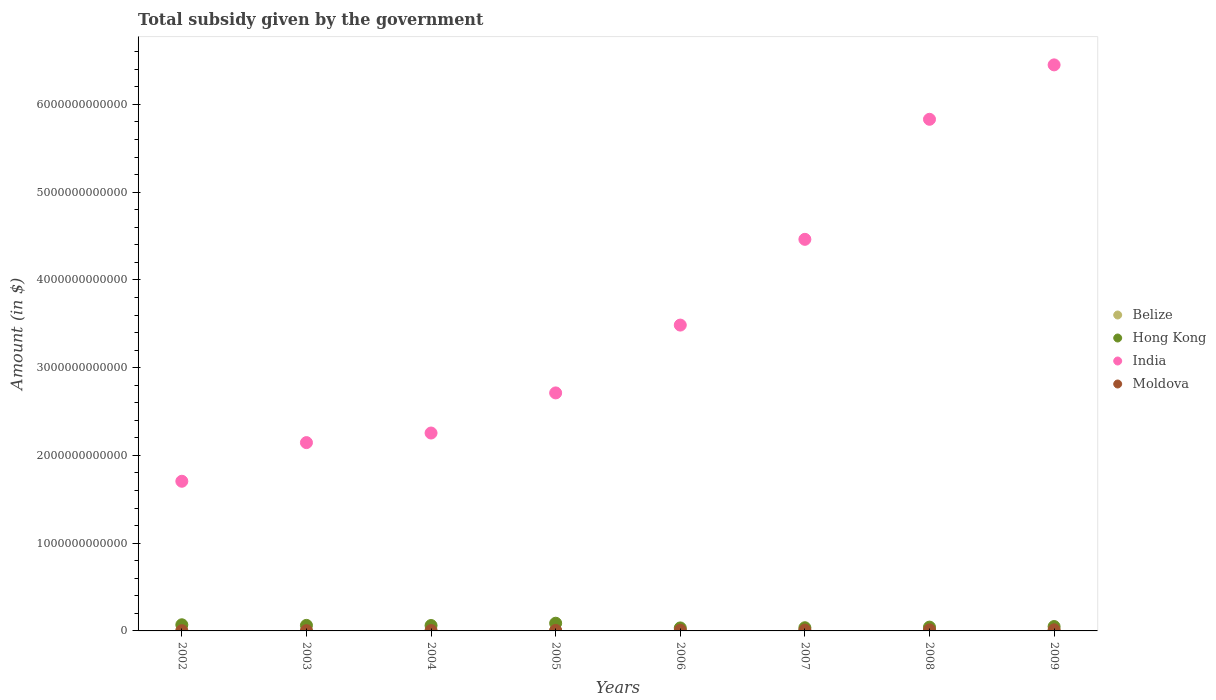How many different coloured dotlines are there?
Offer a very short reply. 4. Is the number of dotlines equal to the number of legend labels?
Make the answer very short. Yes. What is the total revenue collected by the government in Belize in 2003?
Your response must be concise. 5.55e+07. Across all years, what is the maximum total revenue collected by the government in Belize?
Offer a terse response. 1.41e+08. Across all years, what is the minimum total revenue collected by the government in Hong Kong?
Make the answer very short. 3.42e+1. What is the total total revenue collected by the government in Belize in the graph?
Make the answer very short. 7.35e+08. What is the difference between the total revenue collected by the government in India in 2004 and that in 2007?
Make the answer very short. -2.21e+12. What is the difference between the total revenue collected by the government in Hong Kong in 2005 and the total revenue collected by the government in India in 2007?
Keep it short and to the point. -4.37e+12. What is the average total revenue collected by the government in Moldova per year?
Your answer should be compact. 7.33e+09. In the year 2004, what is the difference between the total revenue collected by the government in Hong Kong and total revenue collected by the government in Moldova?
Make the answer very short. 5.74e+1. What is the ratio of the total revenue collected by the government in India in 2003 to that in 2005?
Your answer should be very brief. 0.79. Is the difference between the total revenue collected by the government in Hong Kong in 2006 and 2007 greater than the difference between the total revenue collected by the government in Moldova in 2006 and 2007?
Make the answer very short. No. What is the difference between the highest and the second highest total revenue collected by the government in Moldova?
Your answer should be very brief. 1.18e+09. What is the difference between the highest and the lowest total revenue collected by the government in India?
Offer a terse response. 4.74e+12. Is the total revenue collected by the government in Hong Kong strictly less than the total revenue collected by the government in India over the years?
Make the answer very short. Yes. How many dotlines are there?
Provide a short and direct response. 4. How many years are there in the graph?
Your answer should be compact. 8. What is the difference between two consecutive major ticks on the Y-axis?
Your response must be concise. 1.00e+12. Are the values on the major ticks of Y-axis written in scientific E-notation?
Your answer should be very brief. No. Does the graph contain any zero values?
Ensure brevity in your answer.  No. Where does the legend appear in the graph?
Your response must be concise. Center right. What is the title of the graph?
Keep it short and to the point. Total subsidy given by the government. Does "Korea (Republic)" appear as one of the legend labels in the graph?
Give a very brief answer. No. What is the label or title of the X-axis?
Your answer should be compact. Years. What is the label or title of the Y-axis?
Provide a short and direct response. Amount (in $). What is the Amount (in $) in Belize in 2002?
Offer a very short reply. 5.21e+07. What is the Amount (in $) in Hong Kong in 2002?
Provide a succinct answer. 7.00e+1. What is the Amount (in $) in India in 2002?
Give a very brief answer. 1.71e+12. What is the Amount (in $) of Moldova in 2002?
Your answer should be compact. 2.71e+09. What is the Amount (in $) of Belize in 2003?
Offer a very short reply. 5.55e+07. What is the Amount (in $) in Hong Kong in 2003?
Make the answer very short. 6.32e+1. What is the Amount (in $) in India in 2003?
Ensure brevity in your answer.  2.15e+12. What is the Amount (in $) of Moldova in 2003?
Provide a short and direct response. 3.20e+09. What is the Amount (in $) of Belize in 2004?
Your response must be concise. 6.60e+07. What is the Amount (in $) of Hong Kong in 2004?
Offer a terse response. 6.16e+1. What is the Amount (in $) in India in 2004?
Give a very brief answer. 2.26e+12. What is the Amount (in $) in Moldova in 2004?
Give a very brief answer. 4.26e+09. What is the Amount (in $) in Belize in 2005?
Keep it short and to the point. 7.71e+07. What is the Amount (in $) in Hong Kong in 2005?
Give a very brief answer. 8.78e+1. What is the Amount (in $) of India in 2005?
Provide a short and direct response. 2.71e+12. What is the Amount (in $) of Moldova in 2005?
Your response must be concise. 5.88e+09. What is the Amount (in $) in Belize in 2006?
Your answer should be compact. 9.24e+07. What is the Amount (in $) in Hong Kong in 2006?
Give a very brief answer. 3.42e+1. What is the Amount (in $) in India in 2006?
Provide a short and direct response. 3.49e+12. What is the Amount (in $) in Moldova in 2006?
Ensure brevity in your answer.  8.06e+09. What is the Amount (in $) in Belize in 2007?
Your answer should be very brief. 1.18e+08. What is the Amount (in $) of Hong Kong in 2007?
Your response must be concise. 3.64e+1. What is the Amount (in $) in India in 2007?
Your answer should be compact. 4.46e+12. What is the Amount (in $) in Moldova in 2007?
Provide a short and direct response. 9.77e+09. What is the Amount (in $) in Belize in 2008?
Offer a very short reply. 1.33e+08. What is the Amount (in $) in Hong Kong in 2008?
Make the answer very short. 4.33e+1. What is the Amount (in $) in India in 2008?
Provide a short and direct response. 5.83e+12. What is the Amount (in $) in Moldova in 2008?
Provide a succinct answer. 1.18e+1. What is the Amount (in $) of Belize in 2009?
Offer a very short reply. 1.41e+08. What is the Amount (in $) of Hong Kong in 2009?
Ensure brevity in your answer.  5.00e+1. What is the Amount (in $) of India in 2009?
Ensure brevity in your answer.  6.45e+12. What is the Amount (in $) in Moldova in 2009?
Your answer should be very brief. 1.30e+1. Across all years, what is the maximum Amount (in $) of Belize?
Give a very brief answer. 1.41e+08. Across all years, what is the maximum Amount (in $) of Hong Kong?
Offer a very short reply. 8.78e+1. Across all years, what is the maximum Amount (in $) of India?
Offer a terse response. 6.45e+12. Across all years, what is the maximum Amount (in $) of Moldova?
Ensure brevity in your answer.  1.30e+1. Across all years, what is the minimum Amount (in $) of Belize?
Your answer should be very brief. 5.21e+07. Across all years, what is the minimum Amount (in $) of Hong Kong?
Make the answer very short. 3.42e+1. Across all years, what is the minimum Amount (in $) of India?
Provide a short and direct response. 1.71e+12. Across all years, what is the minimum Amount (in $) in Moldova?
Offer a very short reply. 2.71e+09. What is the total Amount (in $) of Belize in the graph?
Your answer should be very brief. 7.35e+08. What is the total Amount (in $) in Hong Kong in the graph?
Your response must be concise. 4.46e+11. What is the total Amount (in $) of India in the graph?
Offer a very short reply. 2.90e+13. What is the total Amount (in $) in Moldova in the graph?
Your response must be concise. 5.86e+1. What is the difference between the Amount (in $) of Belize in 2002 and that in 2003?
Ensure brevity in your answer.  -3.42e+06. What is the difference between the Amount (in $) of Hong Kong in 2002 and that in 2003?
Offer a terse response. 6.82e+09. What is the difference between the Amount (in $) in India in 2002 and that in 2003?
Provide a short and direct response. -4.40e+11. What is the difference between the Amount (in $) in Moldova in 2002 and that in 2003?
Your response must be concise. -4.92e+08. What is the difference between the Amount (in $) of Belize in 2002 and that in 2004?
Make the answer very short. -1.38e+07. What is the difference between the Amount (in $) of Hong Kong in 2002 and that in 2004?
Keep it short and to the point. 8.37e+09. What is the difference between the Amount (in $) in India in 2002 and that in 2004?
Offer a terse response. -5.50e+11. What is the difference between the Amount (in $) of Moldova in 2002 and that in 2004?
Your response must be concise. -1.55e+09. What is the difference between the Amount (in $) of Belize in 2002 and that in 2005?
Ensure brevity in your answer.  -2.49e+07. What is the difference between the Amount (in $) of Hong Kong in 2002 and that in 2005?
Your answer should be compact. -1.78e+1. What is the difference between the Amount (in $) of India in 2002 and that in 2005?
Make the answer very short. -1.01e+12. What is the difference between the Amount (in $) in Moldova in 2002 and that in 2005?
Keep it short and to the point. -3.17e+09. What is the difference between the Amount (in $) in Belize in 2002 and that in 2006?
Your response must be concise. -4.03e+07. What is the difference between the Amount (in $) in Hong Kong in 2002 and that in 2006?
Provide a short and direct response. 3.58e+1. What is the difference between the Amount (in $) in India in 2002 and that in 2006?
Your answer should be very brief. -1.78e+12. What is the difference between the Amount (in $) of Moldova in 2002 and that in 2006?
Your answer should be compact. -5.35e+09. What is the difference between the Amount (in $) of Belize in 2002 and that in 2007?
Make the answer very short. -6.59e+07. What is the difference between the Amount (in $) in Hong Kong in 2002 and that in 2007?
Offer a terse response. 3.36e+1. What is the difference between the Amount (in $) in India in 2002 and that in 2007?
Your answer should be very brief. -2.76e+12. What is the difference between the Amount (in $) in Moldova in 2002 and that in 2007?
Your response must be concise. -7.06e+09. What is the difference between the Amount (in $) in Belize in 2002 and that in 2008?
Make the answer very short. -8.06e+07. What is the difference between the Amount (in $) of Hong Kong in 2002 and that in 2008?
Ensure brevity in your answer.  2.67e+1. What is the difference between the Amount (in $) of India in 2002 and that in 2008?
Keep it short and to the point. -4.12e+12. What is the difference between the Amount (in $) in Moldova in 2002 and that in 2008?
Give a very brief answer. -9.08e+09. What is the difference between the Amount (in $) in Belize in 2002 and that in 2009?
Give a very brief answer. -8.91e+07. What is the difference between the Amount (in $) in Hong Kong in 2002 and that in 2009?
Offer a terse response. 1.99e+1. What is the difference between the Amount (in $) of India in 2002 and that in 2009?
Ensure brevity in your answer.  -4.74e+12. What is the difference between the Amount (in $) in Moldova in 2002 and that in 2009?
Provide a short and direct response. -1.03e+1. What is the difference between the Amount (in $) of Belize in 2003 and that in 2004?
Provide a succinct answer. -1.04e+07. What is the difference between the Amount (in $) of Hong Kong in 2003 and that in 2004?
Offer a very short reply. 1.55e+09. What is the difference between the Amount (in $) of India in 2003 and that in 2004?
Keep it short and to the point. -1.09e+11. What is the difference between the Amount (in $) in Moldova in 2003 and that in 2004?
Provide a succinct answer. -1.06e+09. What is the difference between the Amount (in $) of Belize in 2003 and that in 2005?
Your response must be concise. -2.15e+07. What is the difference between the Amount (in $) of Hong Kong in 2003 and that in 2005?
Your response must be concise. -2.46e+1. What is the difference between the Amount (in $) of India in 2003 and that in 2005?
Your answer should be very brief. -5.66e+11. What is the difference between the Amount (in $) in Moldova in 2003 and that in 2005?
Your response must be concise. -2.68e+09. What is the difference between the Amount (in $) in Belize in 2003 and that in 2006?
Make the answer very short. -3.68e+07. What is the difference between the Amount (in $) of Hong Kong in 2003 and that in 2006?
Offer a very short reply. 2.90e+1. What is the difference between the Amount (in $) in India in 2003 and that in 2006?
Your answer should be compact. -1.34e+12. What is the difference between the Amount (in $) of Moldova in 2003 and that in 2006?
Your answer should be compact. -4.86e+09. What is the difference between the Amount (in $) of Belize in 2003 and that in 2007?
Your response must be concise. -6.25e+07. What is the difference between the Amount (in $) in Hong Kong in 2003 and that in 2007?
Make the answer very short. 2.68e+1. What is the difference between the Amount (in $) of India in 2003 and that in 2007?
Keep it short and to the point. -2.32e+12. What is the difference between the Amount (in $) in Moldova in 2003 and that in 2007?
Ensure brevity in your answer.  -6.57e+09. What is the difference between the Amount (in $) of Belize in 2003 and that in 2008?
Ensure brevity in your answer.  -7.71e+07. What is the difference between the Amount (in $) in Hong Kong in 2003 and that in 2008?
Give a very brief answer. 1.98e+1. What is the difference between the Amount (in $) of India in 2003 and that in 2008?
Give a very brief answer. -3.68e+12. What is the difference between the Amount (in $) of Moldova in 2003 and that in 2008?
Keep it short and to the point. -8.59e+09. What is the difference between the Amount (in $) of Belize in 2003 and that in 2009?
Make the answer very short. -8.56e+07. What is the difference between the Amount (in $) in Hong Kong in 2003 and that in 2009?
Provide a short and direct response. 1.31e+1. What is the difference between the Amount (in $) of India in 2003 and that in 2009?
Make the answer very short. -4.30e+12. What is the difference between the Amount (in $) in Moldova in 2003 and that in 2009?
Your response must be concise. -9.77e+09. What is the difference between the Amount (in $) in Belize in 2004 and that in 2005?
Keep it short and to the point. -1.11e+07. What is the difference between the Amount (in $) of Hong Kong in 2004 and that in 2005?
Keep it short and to the point. -2.62e+1. What is the difference between the Amount (in $) of India in 2004 and that in 2005?
Provide a succinct answer. -4.57e+11. What is the difference between the Amount (in $) of Moldova in 2004 and that in 2005?
Provide a short and direct response. -1.62e+09. What is the difference between the Amount (in $) in Belize in 2004 and that in 2006?
Provide a short and direct response. -2.64e+07. What is the difference between the Amount (in $) in Hong Kong in 2004 and that in 2006?
Your response must be concise. 2.75e+1. What is the difference between the Amount (in $) in India in 2004 and that in 2006?
Offer a terse response. -1.23e+12. What is the difference between the Amount (in $) in Moldova in 2004 and that in 2006?
Your answer should be compact. -3.80e+09. What is the difference between the Amount (in $) in Belize in 2004 and that in 2007?
Give a very brief answer. -5.20e+07. What is the difference between the Amount (in $) in Hong Kong in 2004 and that in 2007?
Provide a short and direct response. 2.53e+1. What is the difference between the Amount (in $) of India in 2004 and that in 2007?
Provide a succinct answer. -2.21e+12. What is the difference between the Amount (in $) in Moldova in 2004 and that in 2007?
Your answer should be compact. -5.51e+09. What is the difference between the Amount (in $) of Belize in 2004 and that in 2008?
Your answer should be very brief. -6.67e+07. What is the difference between the Amount (in $) of Hong Kong in 2004 and that in 2008?
Provide a short and direct response. 1.83e+1. What is the difference between the Amount (in $) of India in 2004 and that in 2008?
Give a very brief answer. -3.58e+12. What is the difference between the Amount (in $) in Moldova in 2004 and that in 2008?
Ensure brevity in your answer.  -7.53e+09. What is the difference between the Amount (in $) of Belize in 2004 and that in 2009?
Offer a terse response. -7.52e+07. What is the difference between the Amount (in $) of Hong Kong in 2004 and that in 2009?
Provide a short and direct response. 1.16e+1. What is the difference between the Amount (in $) of India in 2004 and that in 2009?
Ensure brevity in your answer.  -4.20e+12. What is the difference between the Amount (in $) in Moldova in 2004 and that in 2009?
Make the answer very short. -8.71e+09. What is the difference between the Amount (in $) in Belize in 2005 and that in 2006?
Provide a short and direct response. -1.53e+07. What is the difference between the Amount (in $) in Hong Kong in 2005 and that in 2006?
Provide a succinct answer. 5.36e+1. What is the difference between the Amount (in $) of India in 2005 and that in 2006?
Offer a very short reply. -7.73e+11. What is the difference between the Amount (in $) in Moldova in 2005 and that in 2006?
Offer a very short reply. -2.18e+09. What is the difference between the Amount (in $) of Belize in 2005 and that in 2007?
Your answer should be very brief. -4.09e+07. What is the difference between the Amount (in $) of Hong Kong in 2005 and that in 2007?
Offer a terse response. 5.14e+1. What is the difference between the Amount (in $) of India in 2005 and that in 2007?
Offer a very short reply. -1.75e+12. What is the difference between the Amount (in $) of Moldova in 2005 and that in 2007?
Ensure brevity in your answer.  -3.89e+09. What is the difference between the Amount (in $) in Belize in 2005 and that in 2008?
Offer a very short reply. -5.56e+07. What is the difference between the Amount (in $) in Hong Kong in 2005 and that in 2008?
Make the answer very short. 4.44e+1. What is the difference between the Amount (in $) in India in 2005 and that in 2008?
Make the answer very short. -3.12e+12. What is the difference between the Amount (in $) in Moldova in 2005 and that in 2008?
Give a very brief answer. -5.91e+09. What is the difference between the Amount (in $) of Belize in 2005 and that in 2009?
Give a very brief answer. -6.41e+07. What is the difference between the Amount (in $) in Hong Kong in 2005 and that in 2009?
Offer a terse response. 3.77e+1. What is the difference between the Amount (in $) in India in 2005 and that in 2009?
Provide a succinct answer. -3.74e+12. What is the difference between the Amount (in $) in Moldova in 2005 and that in 2009?
Provide a short and direct response. -7.09e+09. What is the difference between the Amount (in $) of Belize in 2006 and that in 2007?
Keep it short and to the point. -2.56e+07. What is the difference between the Amount (in $) in Hong Kong in 2006 and that in 2007?
Ensure brevity in your answer.  -2.20e+09. What is the difference between the Amount (in $) of India in 2006 and that in 2007?
Ensure brevity in your answer.  -9.77e+11. What is the difference between the Amount (in $) in Moldova in 2006 and that in 2007?
Make the answer very short. -1.71e+09. What is the difference between the Amount (in $) of Belize in 2006 and that in 2008?
Offer a very short reply. -4.03e+07. What is the difference between the Amount (in $) in Hong Kong in 2006 and that in 2008?
Your response must be concise. -9.17e+09. What is the difference between the Amount (in $) in India in 2006 and that in 2008?
Give a very brief answer. -2.35e+12. What is the difference between the Amount (in $) in Moldova in 2006 and that in 2008?
Your response must be concise. -3.73e+09. What is the difference between the Amount (in $) of Belize in 2006 and that in 2009?
Give a very brief answer. -4.88e+07. What is the difference between the Amount (in $) in Hong Kong in 2006 and that in 2009?
Your answer should be very brief. -1.59e+1. What is the difference between the Amount (in $) of India in 2006 and that in 2009?
Give a very brief answer. -2.97e+12. What is the difference between the Amount (in $) in Moldova in 2006 and that in 2009?
Your answer should be compact. -4.91e+09. What is the difference between the Amount (in $) in Belize in 2007 and that in 2008?
Your response must be concise. -1.47e+07. What is the difference between the Amount (in $) in Hong Kong in 2007 and that in 2008?
Provide a short and direct response. -6.98e+09. What is the difference between the Amount (in $) in India in 2007 and that in 2008?
Keep it short and to the point. -1.37e+12. What is the difference between the Amount (in $) of Moldova in 2007 and that in 2008?
Offer a very short reply. -2.02e+09. What is the difference between the Amount (in $) of Belize in 2007 and that in 2009?
Keep it short and to the point. -2.32e+07. What is the difference between the Amount (in $) of Hong Kong in 2007 and that in 2009?
Provide a succinct answer. -1.37e+1. What is the difference between the Amount (in $) in India in 2007 and that in 2009?
Ensure brevity in your answer.  -1.99e+12. What is the difference between the Amount (in $) in Moldova in 2007 and that in 2009?
Provide a succinct answer. -3.20e+09. What is the difference between the Amount (in $) in Belize in 2008 and that in 2009?
Your answer should be compact. -8.50e+06. What is the difference between the Amount (in $) in Hong Kong in 2008 and that in 2009?
Keep it short and to the point. -6.72e+09. What is the difference between the Amount (in $) in India in 2008 and that in 2009?
Make the answer very short. -6.20e+11. What is the difference between the Amount (in $) of Moldova in 2008 and that in 2009?
Your response must be concise. -1.18e+09. What is the difference between the Amount (in $) of Belize in 2002 and the Amount (in $) of Hong Kong in 2003?
Give a very brief answer. -6.31e+1. What is the difference between the Amount (in $) of Belize in 2002 and the Amount (in $) of India in 2003?
Make the answer very short. -2.15e+12. What is the difference between the Amount (in $) of Belize in 2002 and the Amount (in $) of Moldova in 2003?
Ensure brevity in your answer.  -3.15e+09. What is the difference between the Amount (in $) in Hong Kong in 2002 and the Amount (in $) in India in 2003?
Make the answer very short. -2.08e+12. What is the difference between the Amount (in $) in Hong Kong in 2002 and the Amount (in $) in Moldova in 2003?
Offer a terse response. 6.68e+1. What is the difference between the Amount (in $) of India in 2002 and the Amount (in $) of Moldova in 2003?
Give a very brief answer. 1.70e+12. What is the difference between the Amount (in $) in Belize in 2002 and the Amount (in $) in Hong Kong in 2004?
Your response must be concise. -6.16e+1. What is the difference between the Amount (in $) of Belize in 2002 and the Amount (in $) of India in 2004?
Keep it short and to the point. -2.26e+12. What is the difference between the Amount (in $) of Belize in 2002 and the Amount (in $) of Moldova in 2004?
Ensure brevity in your answer.  -4.21e+09. What is the difference between the Amount (in $) in Hong Kong in 2002 and the Amount (in $) in India in 2004?
Provide a succinct answer. -2.19e+12. What is the difference between the Amount (in $) of Hong Kong in 2002 and the Amount (in $) of Moldova in 2004?
Your response must be concise. 6.57e+1. What is the difference between the Amount (in $) of India in 2002 and the Amount (in $) of Moldova in 2004?
Provide a short and direct response. 1.70e+12. What is the difference between the Amount (in $) in Belize in 2002 and the Amount (in $) in Hong Kong in 2005?
Ensure brevity in your answer.  -8.77e+1. What is the difference between the Amount (in $) of Belize in 2002 and the Amount (in $) of India in 2005?
Offer a very short reply. -2.71e+12. What is the difference between the Amount (in $) in Belize in 2002 and the Amount (in $) in Moldova in 2005?
Ensure brevity in your answer.  -5.83e+09. What is the difference between the Amount (in $) of Hong Kong in 2002 and the Amount (in $) of India in 2005?
Your answer should be compact. -2.64e+12. What is the difference between the Amount (in $) of Hong Kong in 2002 and the Amount (in $) of Moldova in 2005?
Provide a succinct answer. 6.41e+1. What is the difference between the Amount (in $) of India in 2002 and the Amount (in $) of Moldova in 2005?
Offer a terse response. 1.70e+12. What is the difference between the Amount (in $) in Belize in 2002 and the Amount (in $) in Hong Kong in 2006?
Ensure brevity in your answer.  -3.41e+1. What is the difference between the Amount (in $) of Belize in 2002 and the Amount (in $) of India in 2006?
Ensure brevity in your answer.  -3.49e+12. What is the difference between the Amount (in $) in Belize in 2002 and the Amount (in $) in Moldova in 2006?
Provide a succinct answer. -8.01e+09. What is the difference between the Amount (in $) in Hong Kong in 2002 and the Amount (in $) in India in 2006?
Provide a succinct answer. -3.42e+12. What is the difference between the Amount (in $) in Hong Kong in 2002 and the Amount (in $) in Moldova in 2006?
Make the answer very short. 6.19e+1. What is the difference between the Amount (in $) in India in 2002 and the Amount (in $) in Moldova in 2006?
Offer a terse response. 1.70e+12. What is the difference between the Amount (in $) in Belize in 2002 and the Amount (in $) in Hong Kong in 2007?
Offer a terse response. -3.63e+1. What is the difference between the Amount (in $) of Belize in 2002 and the Amount (in $) of India in 2007?
Keep it short and to the point. -4.46e+12. What is the difference between the Amount (in $) in Belize in 2002 and the Amount (in $) in Moldova in 2007?
Offer a very short reply. -9.72e+09. What is the difference between the Amount (in $) of Hong Kong in 2002 and the Amount (in $) of India in 2007?
Make the answer very short. -4.39e+12. What is the difference between the Amount (in $) of Hong Kong in 2002 and the Amount (in $) of Moldova in 2007?
Offer a terse response. 6.02e+1. What is the difference between the Amount (in $) of India in 2002 and the Amount (in $) of Moldova in 2007?
Give a very brief answer. 1.70e+12. What is the difference between the Amount (in $) in Belize in 2002 and the Amount (in $) in Hong Kong in 2008?
Offer a very short reply. -4.33e+1. What is the difference between the Amount (in $) of Belize in 2002 and the Amount (in $) of India in 2008?
Give a very brief answer. -5.83e+12. What is the difference between the Amount (in $) of Belize in 2002 and the Amount (in $) of Moldova in 2008?
Provide a succinct answer. -1.17e+1. What is the difference between the Amount (in $) of Hong Kong in 2002 and the Amount (in $) of India in 2008?
Offer a very short reply. -5.76e+12. What is the difference between the Amount (in $) in Hong Kong in 2002 and the Amount (in $) in Moldova in 2008?
Provide a short and direct response. 5.82e+1. What is the difference between the Amount (in $) of India in 2002 and the Amount (in $) of Moldova in 2008?
Your answer should be compact. 1.69e+12. What is the difference between the Amount (in $) of Belize in 2002 and the Amount (in $) of Hong Kong in 2009?
Provide a short and direct response. -5.00e+1. What is the difference between the Amount (in $) of Belize in 2002 and the Amount (in $) of India in 2009?
Give a very brief answer. -6.45e+12. What is the difference between the Amount (in $) of Belize in 2002 and the Amount (in $) of Moldova in 2009?
Ensure brevity in your answer.  -1.29e+1. What is the difference between the Amount (in $) of Hong Kong in 2002 and the Amount (in $) of India in 2009?
Ensure brevity in your answer.  -6.38e+12. What is the difference between the Amount (in $) in Hong Kong in 2002 and the Amount (in $) in Moldova in 2009?
Provide a short and direct response. 5.70e+1. What is the difference between the Amount (in $) of India in 2002 and the Amount (in $) of Moldova in 2009?
Your response must be concise. 1.69e+12. What is the difference between the Amount (in $) of Belize in 2003 and the Amount (in $) of Hong Kong in 2004?
Keep it short and to the point. -6.16e+1. What is the difference between the Amount (in $) of Belize in 2003 and the Amount (in $) of India in 2004?
Your response must be concise. -2.26e+12. What is the difference between the Amount (in $) of Belize in 2003 and the Amount (in $) of Moldova in 2004?
Provide a succinct answer. -4.20e+09. What is the difference between the Amount (in $) in Hong Kong in 2003 and the Amount (in $) in India in 2004?
Make the answer very short. -2.19e+12. What is the difference between the Amount (in $) in Hong Kong in 2003 and the Amount (in $) in Moldova in 2004?
Keep it short and to the point. 5.89e+1. What is the difference between the Amount (in $) in India in 2003 and the Amount (in $) in Moldova in 2004?
Your response must be concise. 2.14e+12. What is the difference between the Amount (in $) of Belize in 2003 and the Amount (in $) of Hong Kong in 2005?
Give a very brief answer. -8.77e+1. What is the difference between the Amount (in $) of Belize in 2003 and the Amount (in $) of India in 2005?
Your answer should be compact. -2.71e+12. What is the difference between the Amount (in $) of Belize in 2003 and the Amount (in $) of Moldova in 2005?
Make the answer very short. -5.82e+09. What is the difference between the Amount (in $) in Hong Kong in 2003 and the Amount (in $) in India in 2005?
Give a very brief answer. -2.65e+12. What is the difference between the Amount (in $) in Hong Kong in 2003 and the Amount (in $) in Moldova in 2005?
Ensure brevity in your answer.  5.73e+1. What is the difference between the Amount (in $) of India in 2003 and the Amount (in $) of Moldova in 2005?
Your answer should be compact. 2.14e+12. What is the difference between the Amount (in $) of Belize in 2003 and the Amount (in $) of Hong Kong in 2006?
Your answer should be compact. -3.41e+1. What is the difference between the Amount (in $) of Belize in 2003 and the Amount (in $) of India in 2006?
Provide a succinct answer. -3.49e+12. What is the difference between the Amount (in $) in Belize in 2003 and the Amount (in $) in Moldova in 2006?
Ensure brevity in your answer.  -8.01e+09. What is the difference between the Amount (in $) of Hong Kong in 2003 and the Amount (in $) of India in 2006?
Provide a short and direct response. -3.42e+12. What is the difference between the Amount (in $) in Hong Kong in 2003 and the Amount (in $) in Moldova in 2006?
Provide a short and direct response. 5.51e+1. What is the difference between the Amount (in $) in India in 2003 and the Amount (in $) in Moldova in 2006?
Give a very brief answer. 2.14e+12. What is the difference between the Amount (in $) in Belize in 2003 and the Amount (in $) in Hong Kong in 2007?
Provide a short and direct response. -3.63e+1. What is the difference between the Amount (in $) of Belize in 2003 and the Amount (in $) of India in 2007?
Your response must be concise. -4.46e+12. What is the difference between the Amount (in $) in Belize in 2003 and the Amount (in $) in Moldova in 2007?
Make the answer very short. -9.72e+09. What is the difference between the Amount (in $) in Hong Kong in 2003 and the Amount (in $) in India in 2007?
Offer a terse response. -4.40e+12. What is the difference between the Amount (in $) in Hong Kong in 2003 and the Amount (in $) in Moldova in 2007?
Give a very brief answer. 5.34e+1. What is the difference between the Amount (in $) of India in 2003 and the Amount (in $) of Moldova in 2007?
Keep it short and to the point. 2.14e+12. What is the difference between the Amount (in $) of Belize in 2003 and the Amount (in $) of Hong Kong in 2008?
Offer a very short reply. -4.33e+1. What is the difference between the Amount (in $) of Belize in 2003 and the Amount (in $) of India in 2008?
Offer a terse response. -5.83e+12. What is the difference between the Amount (in $) in Belize in 2003 and the Amount (in $) in Moldova in 2008?
Your answer should be compact. -1.17e+1. What is the difference between the Amount (in $) in Hong Kong in 2003 and the Amount (in $) in India in 2008?
Your answer should be very brief. -5.77e+12. What is the difference between the Amount (in $) of Hong Kong in 2003 and the Amount (in $) of Moldova in 2008?
Offer a terse response. 5.14e+1. What is the difference between the Amount (in $) of India in 2003 and the Amount (in $) of Moldova in 2008?
Your response must be concise. 2.13e+12. What is the difference between the Amount (in $) of Belize in 2003 and the Amount (in $) of Hong Kong in 2009?
Your answer should be compact. -5.00e+1. What is the difference between the Amount (in $) in Belize in 2003 and the Amount (in $) in India in 2009?
Your answer should be compact. -6.45e+12. What is the difference between the Amount (in $) of Belize in 2003 and the Amount (in $) of Moldova in 2009?
Give a very brief answer. -1.29e+1. What is the difference between the Amount (in $) of Hong Kong in 2003 and the Amount (in $) of India in 2009?
Provide a succinct answer. -6.39e+12. What is the difference between the Amount (in $) of Hong Kong in 2003 and the Amount (in $) of Moldova in 2009?
Provide a short and direct response. 5.02e+1. What is the difference between the Amount (in $) of India in 2003 and the Amount (in $) of Moldova in 2009?
Offer a terse response. 2.13e+12. What is the difference between the Amount (in $) in Belize in 2004 and the Amount (in $) in Hong Kong in 2005?
Ensure brevity in your answer.  -8.77e+1. What is the difference between the Amount (in $) of Belize in 2004 and the Amount (in $) of India in 2005?
Offer a terse response. -2.71e+12. What is the difference between the Amount (in $) in Belize in 2004 and the Amount (in $) in Moldova in 2005?
Your answer should be very brief. -5.81e+09. What is the difference between the Amount (in $) of Hong Kong in 2004 and the Amount (in $) of India in 2005?
Offer a terse response. -2.65e+12. What is the difference between the Amount (in $) of Hong Kong in 2004 and the Amount (in $) of Moldova in 2005?
Keep it short and to the point. 5.57e+1. What is the difference between the Amount (in $) in India in 2004 and the Amount (in $) in Moldova in 2005?
Offer a very short reply. 2.25e+12. What is the difference between the Amount (in $) of Belize in 2004 and the Amount (in $) of Hong Kong in 2006?
Your answer should be very brief. -3.41e+1. What is the difference between the Amount (in $) of Belize in 2004 and the Amount (in $) of India in 2006?
Ensure brevity in your answer.  -3.49e+12. What is the difference between the Amount (in $) of Belize in 2004 and the Amount (in $) of Moldova in 2006?
Ensure brevity in your answer.  -8.00e+09. What is the difference between the Amount (in $) of Hong Kong in 2004 and the Amount (in $) of India in 2006?
Your response must be concise. -3.42e+12. What is the difference between the Amount (in $) in Hong Kong in 2004 and the Amount (in $) in Moldova in 2006?
Offer a terse response. 5.36e+1. What is the difference between the Amount (in $) in India in 2004 and the Amount (in $) in Moldova in 2006?
Offer a very short reply. 2.25e+12. What is the difference between the Amount (in $) of Belize in 2004 and the Amount (in $) of Hong Kong in 2007?
Give a very brief answer. -3.63e+1. What is the difference between the Amount (in $) in Belize in 2004 and the Amount (in $) in India in 2007?
Your answer should be very brief. -4.46e+12. What is the difference between the Amount (in $) in Belize in 2004 and the Amount (in $) in Moldova in 2007?
Ensure brevity in your answer.  -9.71e+09. What is the difference between the Amount (in $) of Hong Kong in 2004 and the Amount (in $) of India in 2007?
Offer a terse response. -4.40e+12. What is the difference between the Amount (in $) in Hong Kong in 2004 and the Amount (in $) in Moldova in 2007?
Your answer should be compact. 5.18e+1. What is the difference between the Amount (in $) of India in 2004 and the Amount (in $) of Moldova in 2007?
Keep it short and to the point. 2.25e+12. What is the difference between the Amount (in $) in Belize in 2004 and the Amount (in $) in Hong Kong in 2008?
Offer a terse response. -4.33e+1. What is the difference between the Amount (in $) of Belize in 2004 and the Amount (in $) of India in 2008?
Give a very brief answer. -5.83e+12. What is the difference between the Amount (in $) of Belize in 2004 and the Amount (in $) of Moldova in 2008?
Offer a terse response. -1.17e+1. What is the difference between the Amount (in $) in Hong Kong in 2004 and the Amount (in $) in India in 2008?
Give a very brief answer. -5.77e+12. What is the difference between the Amount (in $) of Hong Kong in 2004 and the Amount (in $) of Moldova in 2008?
Make the answer very short. 4.98e+1. What is the difference between the Amount (in $) in India in 2004 and the Amount (in $) in Moldova in 2008?
Keep it short and to the point. 2.24e+12. What is the difference between the Amount (in $) in Belize in 2004 and the Amount (in $) in Hong Kong in 2009?
Your answer should be compact. -5.00e+1. What is the difference between the Amount (in $) of Belize in 2004 and the Amount (in $) of India in 2009?
Your answer should be very brief. -6.45e+12. What is the difference between the Amount (in $) of Belize in 2004 and the Amount (in $) of Moldova in 2009?
Your answer should be very brief. -1.29e+1. What is the difference between the Amount (in $) of Hong Kong in 2004 and the Amount (in $) of India in 2009?
Your response must be concise. -6.39e+12. What is the difference between the Amount (in $) in Hong Kong in 2004 and the Amount (in $) in Moldova in 2009?
Ensure brevity in your answer.  4.86e+1. What is the difference between the Amount (in $) of India in 2004 and the Amount (in $) of Moldova in 2009?
Your response must be concise. 2.24e+12. What is the difference between the Amount (in $) in Belize in 2005 and the Amount (in $) in Hong Kong in 2006?
Offer a very short reply. -3.41e+1. What is the difference between the Amount (in $) of Belize in 2005 and the Amount (in $) of India in 2006?
Your response must be concise. -3.49e+12. What is the difference between the Amount (in $) in Belize in 2005 and the Amount (in $) in Moldova in 2006?
Provide a short and direct response. -7.99e+09. What is the difference between the Amount (in $) of Hong Kong in 2005 and the Amount (in $) of India in 2006?
Keep it short and to the point. -3.40e+12. What is the difference between the Amount (in $) of Hong Kong in 2005 and the Amount (in $) of Moldova in 2006?
Your answer should be compact. 7.97e+1. What is the difference between the Amount (in $) in India in 2005 and the Amount (in $) in Moldova in 2006?
Keep it short and to the point. 2.70e+12. What is the difference between the Amount (in $) of Belize in 2005 and the Amount (in $) of Hong Kong in 2007?
Offer a very short reply. -3.63e+1. What is the difference between the Amount (in $) in Belize in 2005 and the Amount (in $) in India in 2007?
Ensure brevity in your answer.  -4.46e+12. What is the difference between the Amount (in $) of Belize in 2005 and the Amount (in $) of Moldova in 2007?
Offer a very short reply. -9.69e+09. What is the difference between the Amount (in $) in Hong Kong in 2005 and the Amount (in $) in India in 2007?
Offer a terse response. -4.37e+12. What is the difference between the Amount (in $) of Hong Kong in 2005 and the Amount (in $) of Moldova in 2007?
Your response must be concise. 7.80e+1. What is the difference between the Amount (in $) of India in 2005 and the Amount (in $) of Moldova in 2007?
Ensure brevity in your answer.  2.70e+12. What is the difference between the Amount (in $) in Belize in 2005 and the Amount (in $) in Hong Kong in 2008?
Your response must be concise. -4.33e+1. What is the difference between the Amount (in $) of Belize in 2005 and the Amount (in $) of India in 2008?
Your answer should be compact. -5.83e+12. What is the difference between the Amount (in $) in Belize in 2005 and the Amount (in $) in Moldova in 2008?
Offer a terse response. -1.17e+1. What is the difference between the Amount (in $) of Hong Kong in 2005 and the Amount (in $) of India in 2008?
Make the answer very short. -5.74e+12. What is the difference between the Amount (in $) of Hong Kong in 2005 and the Amount (in $) of Moldova in 2008?
Your answer should be compact. 7.60e+1. What is the difference between the Amount (in $) in India in 2005 and the Amount (in $) in Moldova in 2008?
Your answer should be compact. 2.70e+12. What is the difference between the Amount (in $) in Belize in 2005 and the Amount (in $) in Hong Kong in 2009?
Provide a succinct answer. -5.00e+1. What is the difference between the Amount (in $) of Belize in 2005 and the Amount (in $) of India in 2009?
Provide a succinct answer. -6.45e+12. What is the difference between the Amount (in $) of Belize in 2005 and the Amount (in $) of Moldova in 2009?
Provide a short and direct response. -1.29e+1. What is the difference between the Amount (in $) in Hong Kong in 2005 and the Amount (in $) in India in 2009?
Provide a short and direct response. -6.36e+12. What is the difference between the Amount (in $) in Hong Kong in 2005 and the Amount (in $) in Moldova in 2009?
Ensure brevity in your answer.  7.48e+1. What is the difference between the Amount (in $) of India in 2005 and the Amount (in $) of Moldova in 2009?
Offer a terse response. 2.70e+12. What is the difference between the Amount (in $) of Belize in 2006 and the Amount (in $) of Hong Kong in 2007?
Provide a succinct answer. -3.63e+1. What is the difference between the Amount (in $) of Belize in 2006 and the Amount (in $) of India in 2007?
Keep it short and to the point. -4.46e+12. What is the difference between the Amount (in $) of Belize in 2006 and the Amount (in $) of Moldova in 2007?
Make the answer very short. -9.68e+09. What is the difference between the Amount (in $) in Hong Kong in 2006 and the Amount (in $) in India in 2007?
Keep it short and to the point. -4.43e+12. What is the difference between the Amount (in $) in Hong Kong in 2006 and the Amount (in $) in Moldova in 2007?
Make the answer very short. 2.44e+1. What is the difference between the Amount (in $) of India in 2006 and the Amount (in $) of Moldova in 2007?
Keep it short and to the point. 3.48e+12. What is the difference between the Amount (in $) in Belize in 2006 and the Amount (in $) in Hong Kong in 2008?
Provide a short and direct response. -4.32e+1. What is the difference between the Amount (in $) of Belize in 2006 and the Amount (in $) of India in 2008?
Offer a very short reply. -5.83e+12. What is the difference between the Amount (in $) in Belize in 2006 and the Amount (in $) in Moldova in 2008?
Give a very brief answer. -1.17e+1. What is the difference between the Amount (in $) in Hong Kong in 2006 and the Amount (in $) in India in 2008?
Offer a terse response. -5.80e+12. What is the difference between the Amount (in $) in Hong Kong in 2006 and the Amount (in $) in Moldova in 2008?
Offer a terse response. 2.24e+1. What is the difference between the Amount (in $) of India in 2006 and the Amount (in $) of Moldova in 2008?
Offer a terse response. 3.47e+12. What is the difference between the Amount (in $) of Belize in 2006 and the Amount (in $) of Hong Kong in 2009?
Your answer should be very brief. -5.00e+1. What is the difference between the Amount (in $) in Belize in 2006 and the Amount (in $) in India in 2009?
Offer a terse response. -6.45e+12. What is the difference between the Amount (in $) in Belize in 2006 and the Amount (in $) in Moldova in 2009?
Provide a succinct answer. -1.29e+1. What is the difference between the Amount (in $) of Hong Kong in 2006 and the Amount (in $) of India in 2009?
Your answer should be very brief. -6.42e+12. What is the difference between the Amount (in $) of Hong Kong in 2006 and the Amount (in $) of Moldova in 2009?
Give a very brief answer. 2.12e+1. What is the difference between the Amount (in $) in India in 2006 and the Amount (in $) in Moldova in 2009?
Give a very brief answer. 3.47e+12. What is the difference between the Amount (in $) in Belize in 2007 and the Amount (in $) in Hong Kong in 2008?
Provide a succinct answer. -4.32e+1. What is the difference between the Amount (in $) in Belize in 2007 and the Amount (in $) in India in 2008?
Make the answer very short. -5.83e+12. What is the difference between the Amount (in $) in Belize in 2007 and the Amount (in $) in Moldova in 2008?
Your answer should be very brief. -1.17e+1. What is the difference between the Amount (in $) in Hong Kong in 2007 and the Amount (in $) in India in 2008?
Ensure brevity in your answer.  -5.79e+12. What is the difference between the Amount (in $) in Hong Kong in 2007 and the Amount (in $) in Moldova in 2008?
Give a very brief answer. 2.46e+1. What is the difference between the Amount (in $) of India in 2007 and the Amount (in $) of Moldova in 2008?
Offer a terse response. 4.45e+12. What is the difference between the Amount (in $) in Belize in 2007 and the Amount (in $) in Hong Kong in 2009?
Ensure brevity in your answer.  -4.99e+1. What is the difference between the Amount (in $) of Belize in 2007 and the Amount (in $) of India in 2009?
Give a very brief answer. -6.45e+12. What is the difference between the Amount (in $) in Belize in 2007 and the Amount (in $) in Moldova in 2009?
Make the answer very short. -1.29e+1. What is the difference between the Amount (in $) in Hong Kong in 2007 and the Amount (in $) in India in 2009?
Keep it short and to the point. -6.41e+12. What is the difference between the Amount (in $) in Hong Kong in 2007 and the Amount (in $) in Moldova in 2009?
Keep it short and to the point. 2.34e+1. What is the difference between the Amount (in $) in India in 2007 and the Amount (in $) in Moldova in 2009?
Keep it short and to the point. 4.45e+12. What is the difference between the Amount (in $) in Belize in 2008 and the Amount (in $) in Hong Kong in 2009?
Ensure brevity in your answer.  -4.99e+1. What is the difference between the Amount (in $) in Belize in 2008 and the Amount (in $) in India in 2009?
Provide a succinct answer. -6.45e+12. What is the difference between the Amount (in $) in Belize in 2008 and the Amount (in $) in Moldova in 2009?
Offer a terse response. -1.28e+1. What is the difference between the Amount (in $) in Hong Kong in 2008 and the Amount (in $) in India in 2009?
Give a very brief answer. -6.41e+12. What is the difference between the Amount (in $) of Hong Kong in 2008 and the Amount (in $) of Moldova in 2009?
Provide a short and direct response. 3.04e+1. What is the difference between the Amount (in $) in India in 2008 and the Amount (in $) in Moldova in 2009?
Offer a very short reply. 5.82e+12. What is the average Amount (in $) in Belize per year?
Offer a very short reply. 9.19e+07. What is the average Amount (in $) in Hong Kong per year?
Your answer should be very brief. 5.58e+1. What is the average Amount (in $) of India per year?
Your response must be concise. 3.63e+12. What is the average Amount (in $) of Moldova per year?
Provide a short and direct response. 7.33e+09. In the year 2002, what is the difference between the Amount (in $) in Belize and Amount (in $) in Hong Kong?
Provide a succinct answer. -6.99e+1. In the year 2002, what is the difference between the Amount (in $) of Belize and Amount (in $) of India?
Make the answer very short. -1.71e+12. In the year 2002, what is the difference between the Amount (in $) of Belize and Amount (in $) of Moldova?
Give a very brief answer. -2.66e+09. In the year 2002, what is the difference between the Amount (in $) of Hong Kong and Amount (in $) of India?
Your answer should be compact. -1.64e+12. In the year 2002, what is the difference between the Amount (in $) of Hong Kong and Amount (in $) of Moldova?
Provide a succinct answer. 6.73e+1. In the year 2002, what is the difference between the Amount (in $) in India and Amount (in $) in Moldova?
Ensure brevity in your answer.  1.70e+12. In the year 2003, what is the difference between the Amount (in $) of Belize and Amount (in $) of Hong Kong?
Ensure brevity in your answer.  -6.31e+1. In the year 2003, what is the difference between the Amount (in $) of Belize and Amount (in $) of India?
Your response must be concise. -2.15e+12. In the year 2003, what is the difference between the Amount (in $) of Belize and Amount (in $) of Moldova?
Offer a terse response. -3.15e+09. In the year 2003, what is the difference between the Amount (in $) of Hong Kong and Amount (in $) of India?
Offer a very short reply. -2.08e+12. In the year 2003, what is the difference between the Amount (in $) of Hong Kong and Amount (in $) of Moldova?
Give a very brief answer. 6.00e+1. In the year 2003, what is the difference between the Amount (in $) of India and Amount (in $) of Moldova?
Provide a succinct answer. 2.14e+12. In the year 2004, what is the difference between the Amount (in $) in Belize and Amount (in $) in Hong Kong?
Provide a short and direct response. -6.16e+1. In the year 2004, what is the difference between the Amount (in $) in Belize and Amount (in $) in India?
Provide a short and direct response. -2.26e+12. In the year 2004, what is the difference between the Amount (in $) in Belize and Amount (in $) in Moldova?
Make the answer very short. -4.19e+09. In the year 2004, what is the difference between the Amount (in $) in Hong Kong and Amount (in $) in India?
Provide a succinct answer. -2.19e+12. In the year 2004, what is the difference between the Amount (in $) in Hong Kong and Amount (in $) in Moldova?
Make the answer very short. 5.74e+1. In the year 2004, what is the difference between the Amount (in $) of India and Amount (in $) of Moldova?
Provide a succinct answer. 2.25e+12. In the year 2005, what is the difference between the Amount (in $) of Belize and Amount (in $) of Hong Kong?
Give a very brief answer. -8.77e+1. In the year 2005, what is the difference between the Amount (in $) of Belize and Amount (in $) of India?
Keep it short and to the point. -2.71e+12. In the year 2005, what is the difference between the Amount (in $) in Belize and Amount (in $) in Moldova?
Give a very brief answer. -5.80e+09. In the year 2005, what is the difference between the Amount (in $) in Hong Kong and Amount (in $) in India?
Your response must be concise. -2.62e+12. In the year 2005, what is the difference between the Amount (in $) in Hong Kong and Amount (in $) in Moldova?
Your answer should be compact. 8.19e+1. In the year 2005, what is the difference between the Amount (in $) of India and Amount (in $) of Moldova?
Ensure brevity in your answer.  2.71e+12. In the year 2006, what is the difference between the Amount (in $) in Belize and Amount (in $) in Hong Kong?
Keep it short and to the point. -3.41e+1. In the year 2006, what is the difference between the Amount (in $) of Belize and Amount (in $) of India?
Give a very brief answer. -3.49e+12. In the year 2006, what is the difference between the Amount (in $) in Belize and Amount (in $) in Moldova?
Your response must be concise. -7.97e+09. In the year 2006, what is the difference between the Amount (in $) in Hong Kong and Amount (in $) in India?
Ensure brevity in your answer.  -3.45e+12. In the year 2006, what is the difference between the Amount (in $) in Hong Kong and Amount (in $) in Moldova?
Your answer should be compact. 2.61e+1. In the year 2006, what is the difference between the Amount (in $) in India and Amount (in $) in Moldova?
Your answer should be very brief. 3.48e+12. In the year 2007, what is the difference between the Amount (in $) of Belize and Amount (in $) of Hong Kong?
Give a very brief answer. -3.62e+1. In the year 2007, what is the difference between the Amount (in $) in Belize and Amount (in $) in India?
Offer a very short reply. -4.46e+12. In the year 2007, what is the difference between the Amount (in $) of Belize and Amount (in $) of Moldova?
Provide a short and direct response. -9.65e+09. In the year 2007, what is the difference between the Amount (in $) of Hong Kong and Amount (in $) of India?
Your answer should be very brief. -4.43e+12. In the year 2007, what is the difference between the Amount (in $) in Hong Kong and Amount (in $) in Moldova?
Make the answer very short. 2.66e+1. In the year 2007, what is the difference between the Amount (in $) of India and Amount (in $) of Moldova?
Ensure brevity in your answer.  4.45e+12. In the year 2008, what is the difference between the Amount (in $) of Belize and Amount (in $) of Hong Kong?
Your response must be concise. -4.32e+1. In the year 2008, what is the difference between the Amount (in $) in Belize and Amount (in $) in India?
Provide a succinct answer. -5.83e+12. In the year 2008, what is the difference between the Amount (in $) in Belize and Amount (in $) in Moldova?
Your response must be concise. -1.17e+1. In the year 2008, what is the difference between the Amount (in $) in Hong Kong and Amount (in $) in India?
Offer a terse response. -5.79e+12. In the year 2008, what is the difference between the Amount (in $) of Hong Kong and Amount (in $) of Moldova?
Your answer should be compact. 3.15e+1. In the year 2008, what is the difference between the Amount (in $) in India and Amount (in $) in Moldova?
Give a very brief answer. 5.82e+12. In the year 2009, what is the difference between the Amount (in $) in Belize and Amount (in $) in Hong Kong?
Your response must be concise. -4.99e+1. In the year 2009, what is the difference between the Amount (in $) in Belize and Amount (in $) in India?
Your response must be concise. -6.45e+12. In the year 2009, what is the difference between the Amount (in $) of Belize and Amount (in $) of Moldova?
Your response must be concise. -1.28e+1. In the year 2009, what is the difference between the Amount (in $) of Hong Kong and Amount (in $) of India?
Ensure brevity in your answer.  -6.40e+12. In the year 2009, what is the difference between the Amount (in $) in Hong Kong and Amount (in $) in Moldova?
Ensure brevity in your answer.  3.71e+1. In the year 2009, what is the difference between the Amount (in $) of India and Amount (in $) of Moldova?
Give a very brief answer. 6.44e+12. What is the ratio of the Amount (in $) in Belize in 2002 to that in 2003?
Ensure brevity in your answer.  0.94. What is the ratio of the Amount (in $) in Hong Kong in 2002 to that in 2003?
Offer a very short reply. 1.11. What is the ratio of the Amount (in $) of India in 2002 to that in 2003?
Your answer should be very brief. 0.79. What is the ratio of the Amount (in $) of Moldova in 2002 to that in 2003?
Ensure brevity in your answer.  0.85. What is the ratio of the Amount (in $) in Belize in 2002 to that in 2004?
Make the answer very short. 0.79. What is the ratio of the Amount (in $) of Hong Kong in 2002 to that in 2004?
Offer a terse response. 1.14. What is the ratio of the Amount (in $) of India in 2002 to that in 2004?
Make the answer very short. 0.76. What is the ratio of the Amount (in $) in Moldova in 2002 to that in 2004?
Keep it short and to the point. 0.64. What is the ratio of the Amount (in $) in Belize in 2002 to that in 2005?
Your answer should be compact. 0.68. What is the ratio of the Amount (in $) of Hong Kong in 2002 to that in 2005?
Your response must be concise. 0.8. What is the ratio of the Amount (in $) in India in 2002 to that in 2005?
Ensure brevity in your answer.  0.63. What is the ratio of the Amount (in $) in Moldova in 2002 to that in 2005?
Make the answer very short. 0.46. What is the ratio of the Amount (in $) in Belize in 2002 to that in 2006?
Ensure brevity in your answer.  0.56. What is the ratio of the Amount (in $) of Hong Kong in 2002 to that in 2006?
Your answer should be very brief. 2.05. What is the ratio of the Amount (in $) in India in 2002 to that in 2006?
Provide a succinct answer. 0.49. What is the ratio of the Amount (in $) in Moldova in 2002 to that in 2006?
Keep it short and to the point. 0.34. What is the ratio of the Amount (in $) in Belize in 2002 to that in 2007?
Your answer should be very brief. 0.44. What is the ratio of the Amount (in $) of Hong Kong in 2002 to that in 2007?
Offer a terse response. 1.93. What is the ratio of the Amount (in $) of India in 2002 to that in 2007?
Keep it short and to the point. 0.38. What is the ratio of the Amount (in $) of Moldova in 2002 to that in 2007?
Make the answer very short. 0.28. What is the ratio of the Amount (in $) in Belize in 2002 to that in 2008?
Your answer should be compact. 0.39. What is the ratio of the Amount (in $) in Hong Kong in 2002 to that in 2008?
Your response must be concise. 1.62. What is the ratio of the Amount (in $) of India in 2002 to that in 2008?
Your answer should be very brief. 0.29. What is the ratio of the Amount (in $) in Moldova in 2002 to that in 2008?
Offer a very short reply. 0.23. What is the ratio of the Amount (in $) of Belize in 2002 to that in 2009?
Your response must be concise. 0.37. What is the ratio of the Amount (in $) of Hong Kong in 2002 to that in 2009?
Provide a short and direct response. 1.4. What is the ratio of the Amount (in $) of India in 2002 to that in 2009?
Your answer should be very brief. 0.26. What is the ratio of the Amount (in $) of Moldova in 2002 to that in 2009?
Make the answer very short. 0.21. What is the ratio of the Amount (in $) in Belize in 2003 to that in 2004?
Offer a very short reply. 0.84. What is the ratio of the Amount (in $) in Hong Kong in 2003 to that in 2004?
Keep it short and to the point. 1.03. What is the ratio of the Amount (in $) in India in 2003 to that in 2004?
Offer a terse response. 0.95. What is the ratio of the Amount (in $) of Moldova in 2003 to that in 2004?
Keep it short and to the point. 0.75. What is the ratio of the Amount (in $) of Belize in 2003 to that in 2005?
Give a very brief answer. 0.72. What is the ratio of the Amount (in $) of Hong Kong in 2003 to that in 2005?
Your answer should be compact. 0.72. What is the ratio of the Amount (in $) of India in 2003 to that in 2005?
Your answer should be very brief. 0.79. What is the ratio of the Amount (in $) in Moldova in 2003 to that in 2005?
Your answer should be compact. 0.54. What is the ratio of the Amount (in $) in Belize in 2003 to that in 2006?
Offer a very short reply. 0.6. What is the ratio of the Amount (in $) of Hong Kong in 2003 to that in 2006?
Offer a very short reply. 1.85. What is the ratio of the Amount (in $) of India in 2003 to that in 2006?
Give a very brief answer. 0.62. What is the ratio of the Amount (in $) of Moldova in 2003 to that in 2006?
Provide a succinct answer. 0.4. What is the ratio of the Amount (in $) of Belize in 2003 to that in 2007?
Ensure brevity in your answer.  0.47. What is the ratio of the Amount (in $) in Hong Kong in 2003 to that in 2007?
Your answer should be compact. 1.74. What is the ratio of the Amount (in $) of India in 2003 to that in 2007?
Offer a terse response. 0.48. What is the ratio of the Amount (in $) of Moldova in 2003 to that in 2007?
Your answer should be very brief. 0.33. What is the ratio of the Amount (in $) in Belize in 2003 to that in 2008?
Your answer should be very brief. 0.42. What is the ratio of the Amount (in $) of Hong Kong in 2003 to that in 2008?
Your answer should be very brief. 1.46. What is the ratio of the Amount (in $) of India in 2003 to that in 2008?
Give a very brief answer. 0.37. What is the ratio of the Amount (in $) of Moldova in 2003 to that in 2008?
Your response must be concise. 0.27. What is the ratio of the Amount (in $) in Belize in 2003 to that in 2009?
Your answer should be very brief. 0.39. What is the ratio of the Amount (in $) in Hong Kong in 2003 to that in 2009?
Your response must be concise. 1.26. What is the ratio of the Amount (in $) in India in 2003 to that in 2009?
Provide a short and direct response. 0.33. What is the ratio of the Amount (in $) in Moldova in 2003 to that in 2009?
Offer a terse response. 0.25. What is the ratio of the Amount (in $) of Belize in 2004 to that in 2005?
Provide a short and direct response. 0.86. What is the ratio of the Amount (in $) of Hong Kong in 2004 to that in 2005?
Ensure brevity in your answer.  0.7. What is the ratio of the Amount (in $) in India in 2004 to that in 2005?
Offer a very short reply. 0.83. What is the ratio of the Amount (in $) in Moldova in 2004 to that in 2005?
Provide a succinct answer. 0.72. What is the ratio of the Amount (in $) of Belize in 2004 to that in 2006?
Offer a terse response. 0.71. What is the ratio of the Amount (in $) in Hong Kong in 2004 to that in 2006?
Provide a succinct answer. 1.8. What is the ratio of the Amount (in $) of India in 2004 to that in 2006?
Offer a terse response. 0.65. What is the ratio of the Amount (in $) in Moldova in 2004 to that in 2006?
Offer a very short reply. 0.53. What is the ratio of the Amount (in $) in Belize in 2004 to that in 2007?
Make the answer very short. 0.56. What is the ratio of the Amount (in $) in Hong Kong in 2004 to that in 2007?
Give a very brief answer. 1.7. What is the ratio of the Amount (in $) of India in 2004 to that in 2007?
Keep it short and to the point. 0.51. What is the ratio of the Amount (in $) of Moldova in 2004 to that in 2007?
Your answer should be very brief. 0.44. What is the ratio of the Amount (in $) in Belize in 2004 to that in 2008?
Offer a terse response. 0.5. What is the ratio of the Amount (in $) of Hong Kong in 2004 to that in 2008?
Offer a very short reply. 1.42. What is the ratio of the Amount (in $) in India in 2004 to that in 2008?
Your response must be concise. 0.39. What is the ratio of the Amount (in $) of Moldova in 2004 to that in 2008?
Offer a terse response. 0.36. What is the ratio of the Amount (in $) in Belize in 2004 to that in 2009?
Provide a short and direct response. 0.47. What is the ratio of the Amount (in $) of Hong Kong in 2004 to that in 2009?
Give a very brief answer. 1.23. What is the ratio of the Amount (in $) in India in 2004 to that in 2009?
Offer a very short reply. 0.35. What is the ratio of the Amount (in $) of Moldova in 2004 to that in 2009?
Provide a succinct answer. 0.33. What is the ratio of the Amount (in $) in Belize in 2005 to that in 2006?
Your answer should be very brief. 0.83. What is the ratio of the Amount (in $) of Hong Kong in 2005 to that in 2006?
Keep it short and to the point. 2.57. What is the ratio of the Amount (in $) in India in 2005 to that in 2006?
Make the answer very short. 0.78. What is the ratio of the Amount (in $) in Moldova in 2005 to that in 2006?
Ensure brevity in your answer.  0.73. What is the ratio of the Amount (in $) of Belize in 2005 to that in 2007?
Provide a succinct answer. 0.65. What is the ratio of the Amount (in $) in Hong Kong in 2005 to that in 2007?
Offer a terse response. 2.41. What is the ratio of the Amount (in $) in India in 2005 to that in 2007?
Ensure brevity in your answer.  0.61. What is the ratio of the Amount (in $) of Moldova in 2005 to that in 2007?
Ensure brevity in your answer.  0.6. What is the ratio of the Amount (in $) in Belize in 2005 to that in 2008?
Offer a terse response. 0.58. What is the ratio of the Amount (in $) of Hong Kong in 2005 to that in 2008?
Provide a succinct answer. 2.03. What is the ratio of the Amount (in $) in India in 2005 to that in 2008?
Provide a succinct answer. 0.47. What is the ratio of the Amount (in $) in Moldova in 2005 to that in 2008?
Your answer should be very brief. 0.5. What is the ratio of the Amount (in $) of Belize in 2005 to that in 2009?
Make the answer very short. 0.55. What is the ratio of the Amount (in $) in Hong Kong in 2005 to that in 2009?
Keep it short and to the point. 1.75. What is the ratio of the Amount (in $) in India in 2005 to that in 2009?
Your answer should be compact. 0.42. What is the ratio of the Amount (in $) in Moldova in 2005 to that in 2009?
Ensure brevity in your answer.  0.45. What is the ratio of the Amount (in $) of Belize in 2006 to that in 2007?
Provide a short and direct response. 0.78. What is the ratio of the Amount (in $) in Hong Kong in 2006 to that in 2007?
Your response must be concise. 0.94. What is the ratio of the Amount (in $) in India in 2006 to that in 2007?
Your answer should be very brief. 0.78. What is the ratio of the Amount (in $) of Moldova in 2006 to that in 2007?
Offer a very short reply. 0.83. What is the ratio of the Amount (in $) in Belize in 2006 to that in 2008?
Keep it short and to the point. 0.7. What is the ratio of the Amount (in $) in Hong Kong in 2006 to that in 2008?
Your answer should be very brief. 0.79. What is the ratio of the Amount (in $) in India in 2006 to that in 2008?
Give a very brief answer. 0.6. What is the ratio of the Amount (in $) of Moldova in 2006 to that in 2008?
Make the answer very short. 0.68. What is the ratio of the Amount (in $) of Belize in 2006 to that in 2009?
Offer a terse response. 0.65. What is the ratio of the Amount (in $) in Hong Kong in 2006 to that in 2009?
Keep it short and to the point. 0.68. What is the ratio of the Amount (in $) of India in 2006 to that in 2009?
Give a very brief answer. 0.54. What is the ratio of the Amount (in $) of Moldova in 2006 to that in 2009?
Provide a succinct answer. 0.62. What is the ratio of the Amount (in $) in Belize in 2007 to that in 2008?
Ensure brevity in your answer.  0.89. What is the ratio of the Amount (in $) of Hong Kong in 2007 to that in 2008?
Offer a terse response. 0.84. What is the ratio of the Amount (in $) of India in 2007 to that in 2008?
Your response must be concise. 0.77. What is the ratio of the Amount (in $) of Moldova in 2007 to that in 2008?
Ensure brevity in your answer.  0.83. What is the ratio of the Amount (in $) in Belize in 2007 to that in 2009?
Your answer should be very brief. 0.84. What is the ratio of the Amount (in $) in Hong Kong in 2007 to that in 2009?
Provide a short and direct response. 0.73. What is the ratio of the Amount (in $) in India in 2007 to that in 2009?
Give a very brief answer. 0.69. What is the ratio of the Amount (in $) of Moldova in 2007 to that in 2009?
Offer a terse response. 0.75. What is the ratio of the Amount (in $) in Belize in 2008 to that in 2009?
Your response must be concise. 0.94. What is the ratio of the Amount (in $) of Hong Kong in 2008 to that in 2009?
Offer a very short reply. 0.87. What is the ratio of the Amount (in $) of India in 2008 to that in 2009?
Give a very brief answer. 0.9. What is the ratio of the Amount (in $) in Moldova in 2008 to that in 2009?
Keep it short and to the point. 0.91. What is the difference between the highest and the second highest Amount (in $) in Belize?
Ensure brevity in your answer.  8.50e+06. What is the difference between the highest and the second highest Amount (in $) of Hong Kong?
Your response must be concise. 1.78e+1. What is the difference between the highest and the second highest Amount (in $) in India?
Keep it short and to the point. 6.20e+11. What is the difference between the highest and the second highest Amount (in $) of Moldova?
Your response must be concise. 1.18e+09. What is the difference between the highest and the lowest Amount (in $) in Belize?
Provide a short and direct response. 8.91e+07. What is the difference between the highest and the lowest Amount (in $) of Hong Kong?
Your answer should be compact. 5.36e+1. What is the difference between the highest and the lowest Amount (in $) in India?
Make the answer very short. 4.74e+12. What is the difference between the highest and the lowest Amount (in $) of Moldova?
Keep it short and to the point. 1.03e+1. 